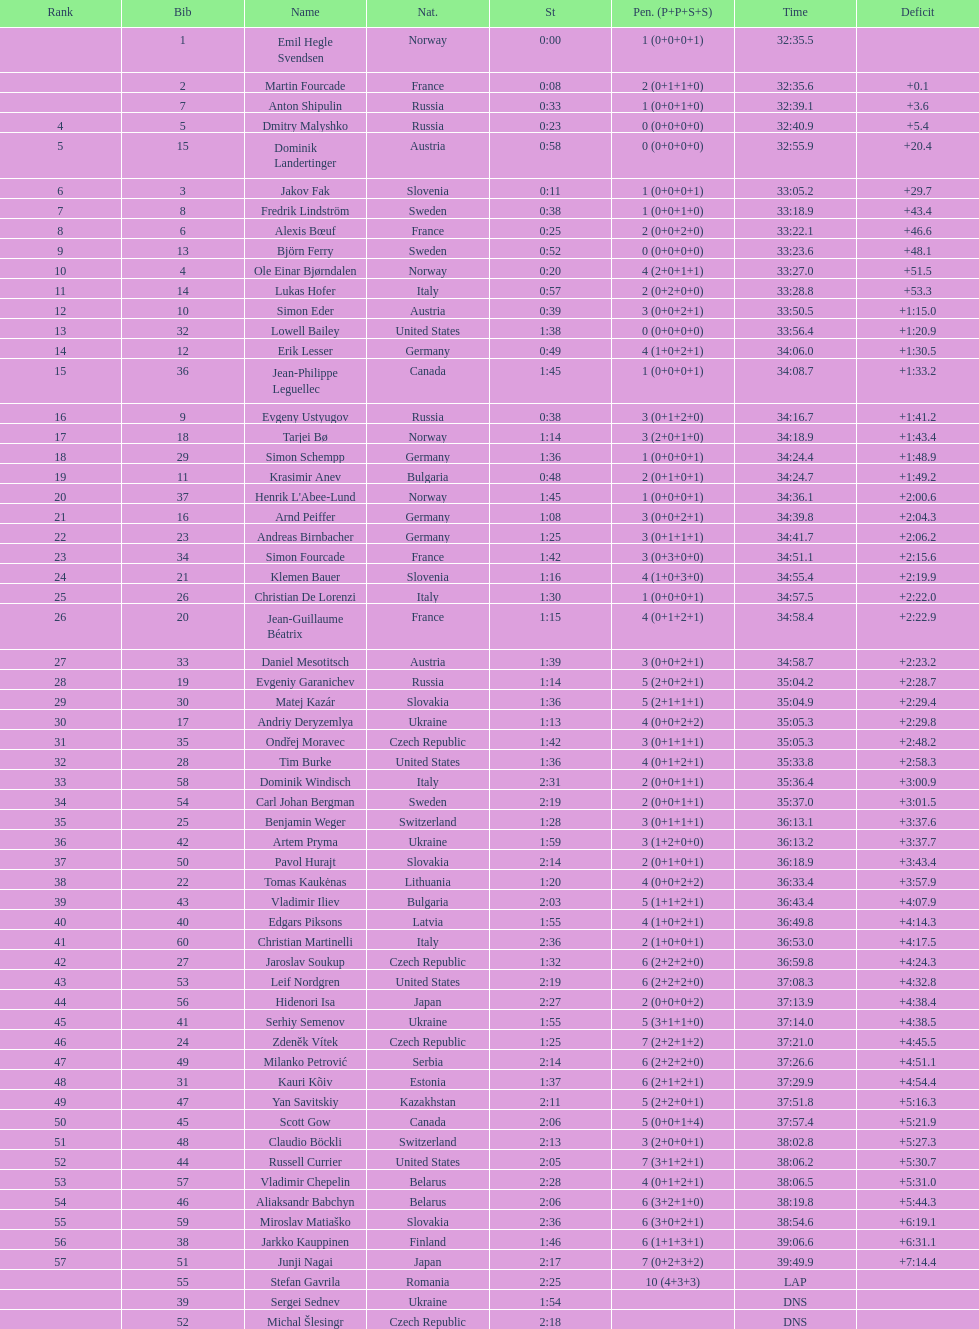Other than burke, name an athlete from the us. Leif Nordgren. 